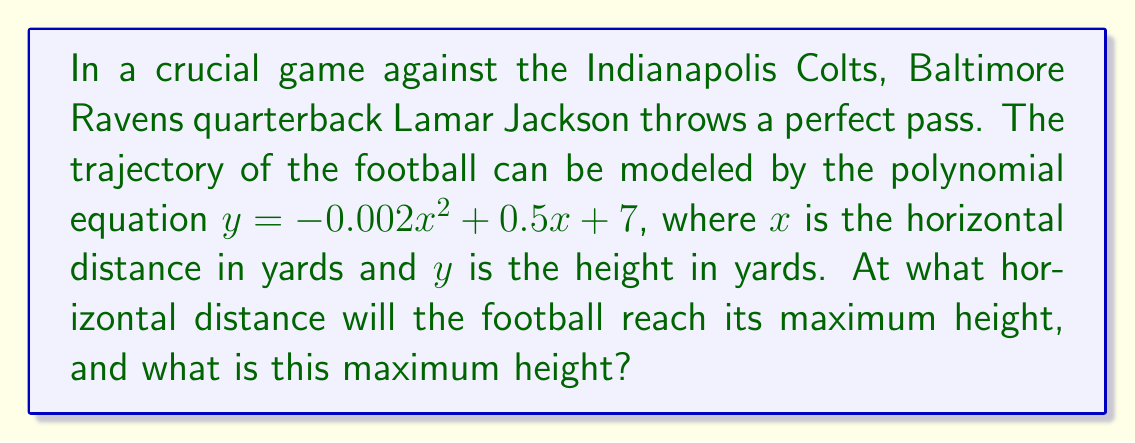Can you answer this question? To solve this problem, we'll follow these steps:

1) The trajectory is given by the quadratic equation $y = -0.002x^2 + 0.5x + 7$

2) To find the maximum height, we need to find the vertex of this parabola. For a quadratic equation in the form $y = ax^2 + bx + c$, the x-coordinate of the vertex is given by $x = -\frac{b}{2a}$

3) In our equation:
   $a = -0.002$
   $b = 0.5$
   $c = 7$

4) Plugging into the vertex formula:
   $$x = -\frac{0.5}{2(-0.002)} = -\frac{0.5}{-0.004} = 125$$

5) This means the football reaches its maximum height 125 yards horizontally from the throw.

6) To find the maximum height, we substitute this x-value back into our original equation:

   $$y = -0.002(125)^2 + 0.5(125) + 7$$
   $$y = -0.002(15625) + 62.5 + 7$$
   $$y = -31.25 + 62.5 + 7$$
   $$y = 38.25$$

Therefore, the maximum height reached is 38.25 yards.
Answer: 125 yards horizontally; 38.25 yards high 